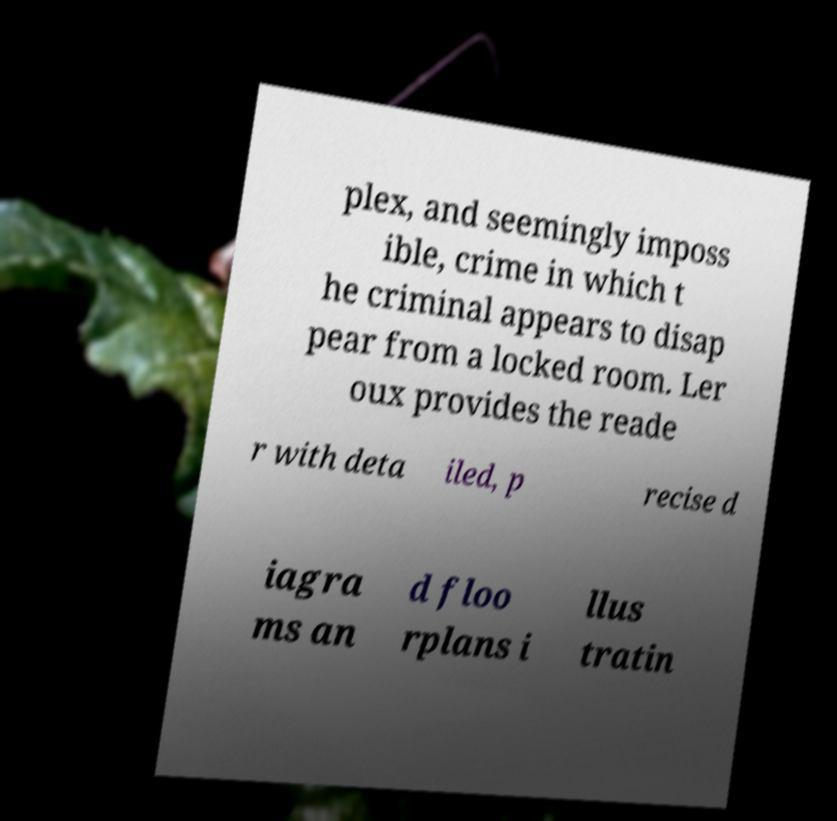Could you assist in decoding the text presented in this image and type it out clearly? plex, and seemingly imposs ible, crime in which t he criminal appears to disap pear from a locked room. Ler oux provides the reade r with deta iled, p recise d iagra ms an d floo rplans i llus tratin 